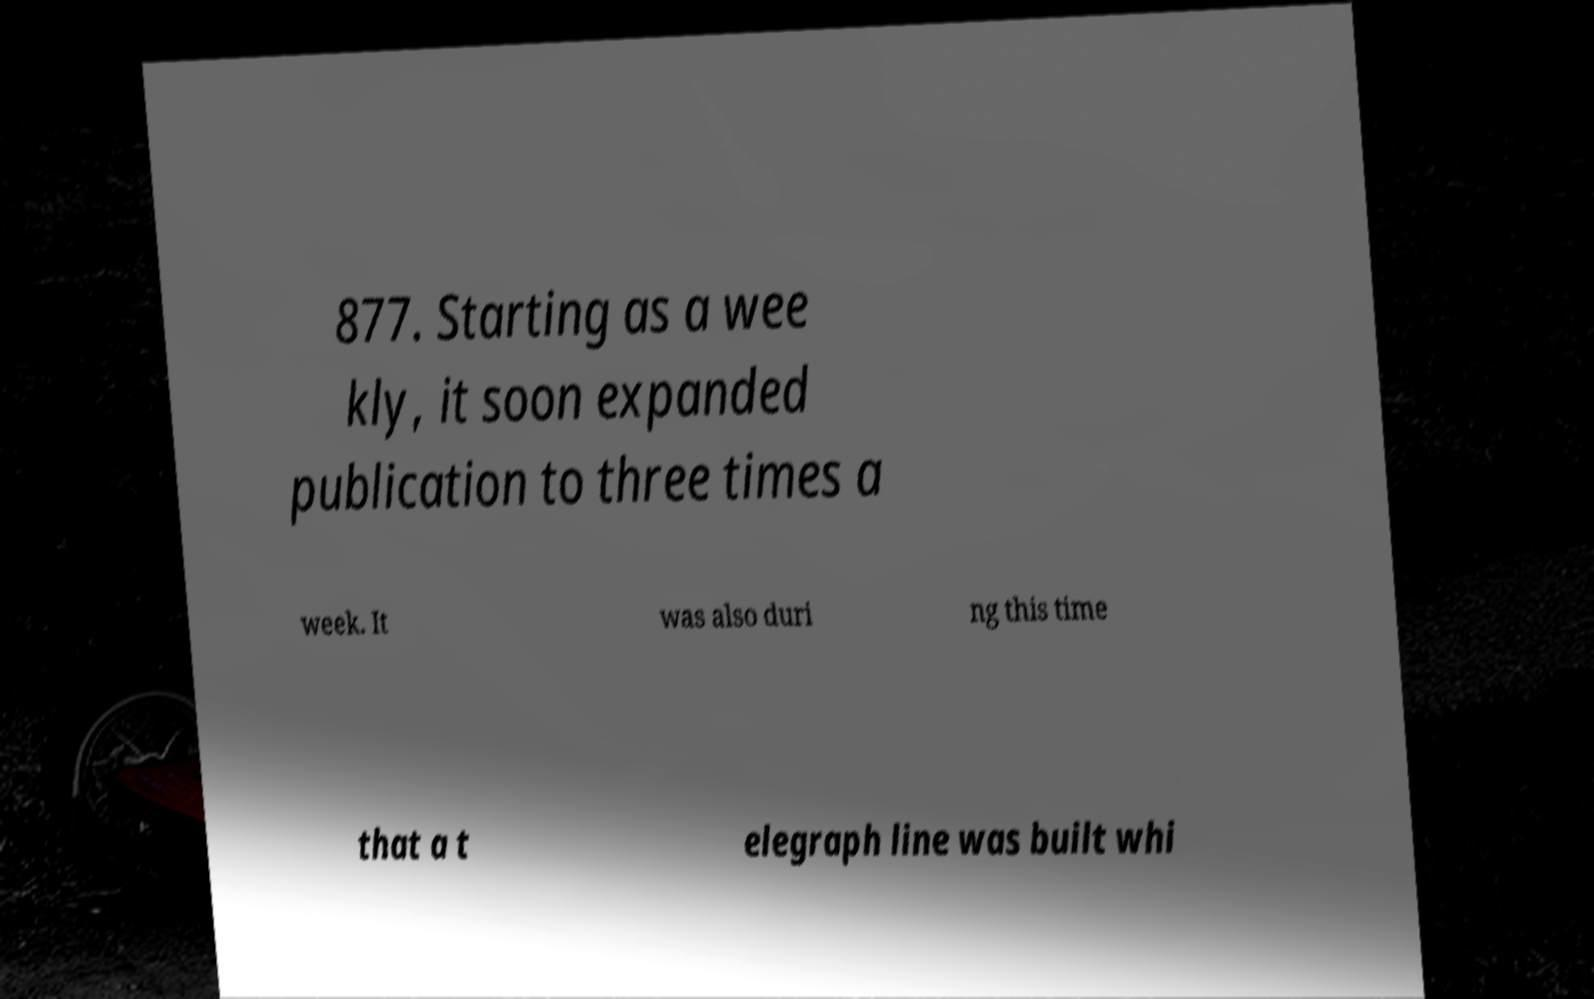Please read and relay the text visible in this image. What does it say? 877. Starting as a wee kly, it soon expanded publication to three times a week. It was also duri ng this time that a t elegraph line was built whi 